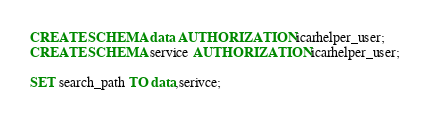Convert code to text. <code><loc_0><loc_0><loc_500><loc_500><_SQL_>CREATE SCHEMA data AUTHORIZATION icarhelper_user;
CREATE SCHEMA service AUTHORIZATION icarhelper_user;

SET search_path TO data,serivce;</code> 